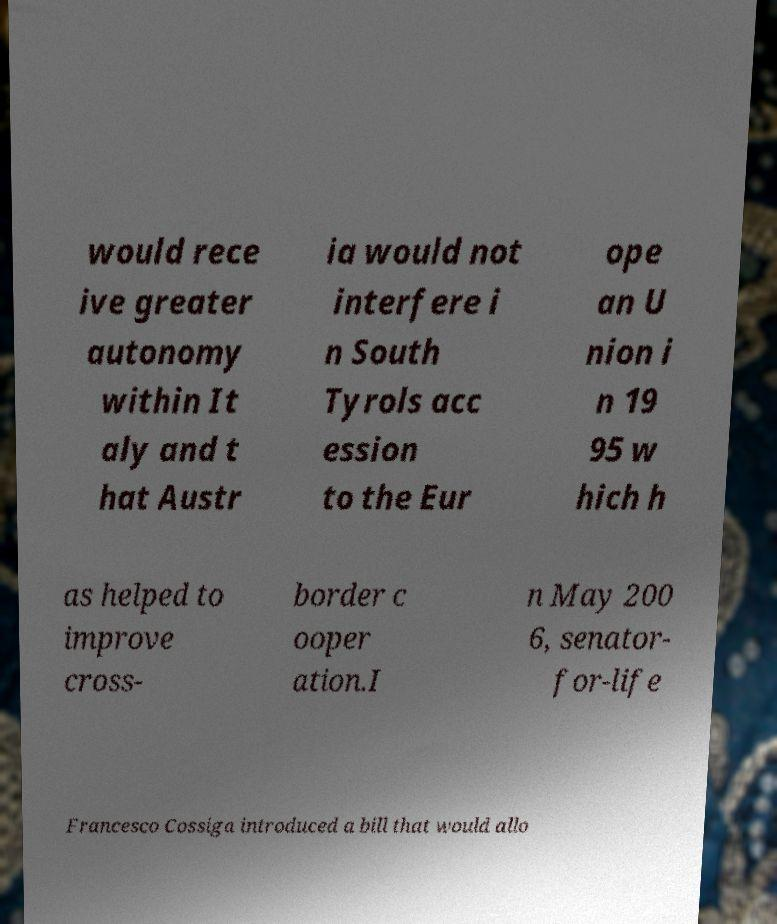I need the written content from this picture converted into text. Can you do that? would rece ive greater autonomy within It aly and t hat Austr ia would not interfere i n South Tyrols acc ession to the Eur ope an U nion i n 19 95 w hich h as helped to improve cross- border c ooper ation.I n May 200 6, senator- for-life Francesco Cossiga introduced a bill that would allo 